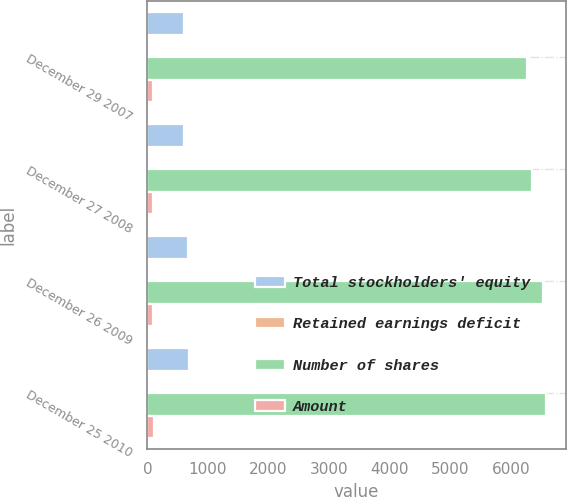Convert chart to OTSL. <chart><loc_0><loc_0><loc_500><loc_500><stacked_bar_chart><ecel><fcel>December 29 2007<fcel>December 27 2008<fcel>December 26 2009<fcel>December 25 2010<nl><fcel>Total stockholders' equity<fcel>606<fcel>609<fcel>671<fcel>683<nl><fcel>Retained earnings deficit<fcel>6<fcel>6<fcel>7<fcel>7<nl><fcel>Number of shares<fcel>6271<fcel>6354<fcel>6524<fcel>6575<nl><fcel>Amount<fcel>95<fcel>97<fcel>98<fcel>102<nl></chart> 